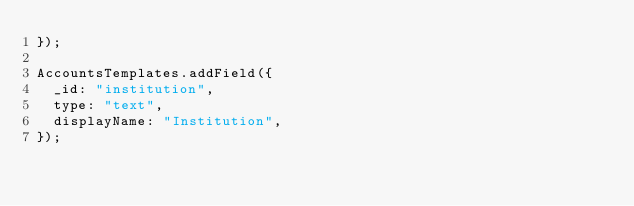<code> <loc_0><loc_0><loc_500><loc_500><_JavaScript_>});

AccountsTemplates.addField({
  _id: "institution",
  type: "text",
  displayName: "Institution",
});
</code> 